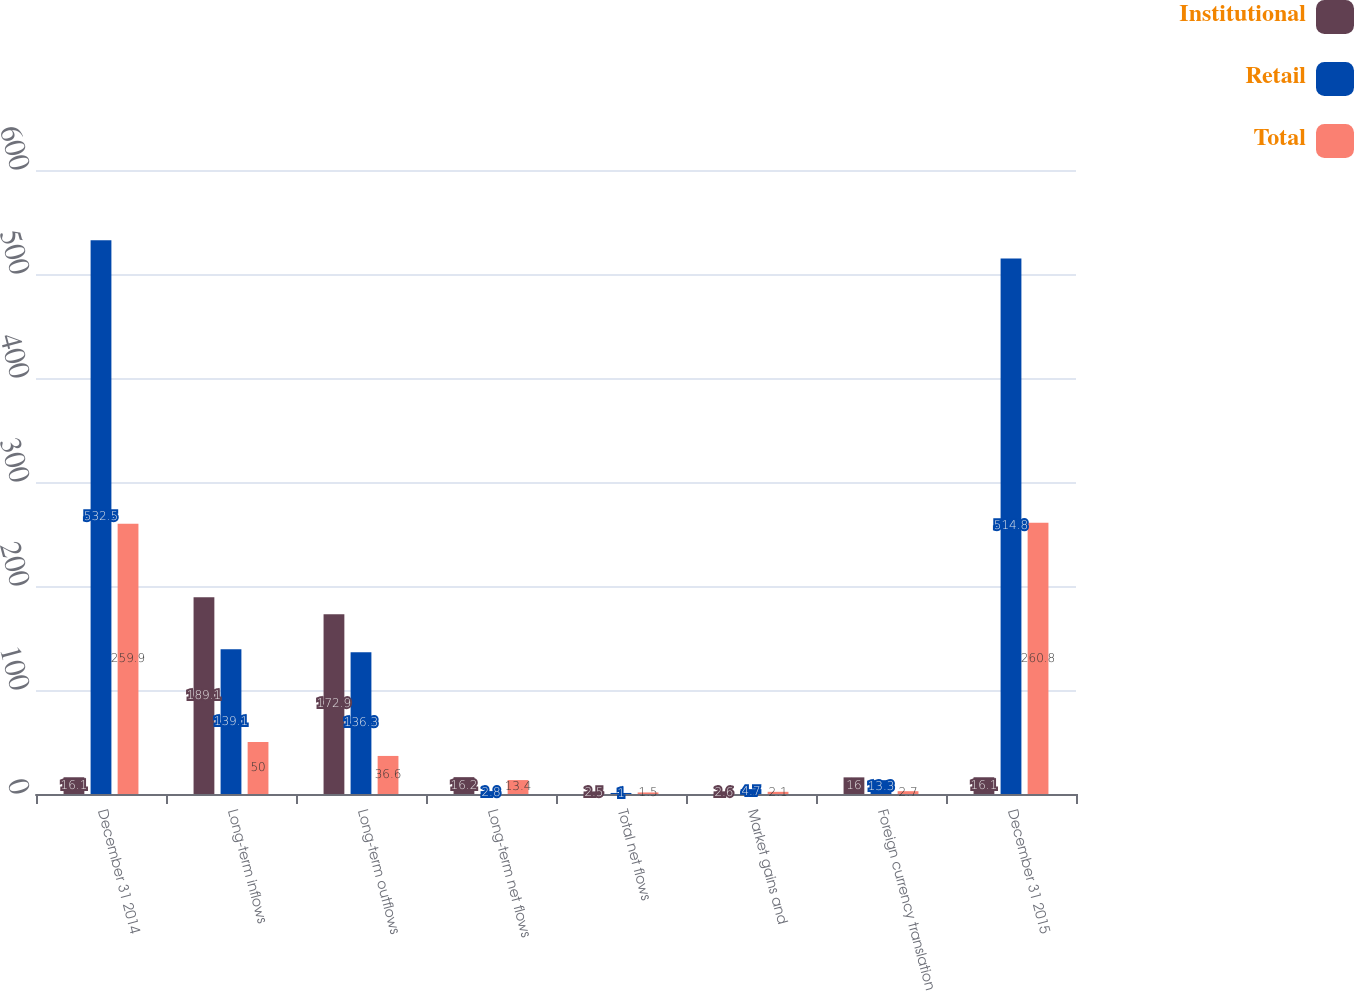Convert chart. <chart><loc_0><loc_0><loc_500><loc_500><stacked_bar_chart><ecel><fcel>December 31 2014<fcel>Long-term inflows<fcel>Long-term outflows<fcel>Long-term net flows<fcel>Total net flows<fcel>Market gains and<fcel>Foreign currency translation<fcel>December 31 2015<nl><fcel>Institutional<fcel>16.1<fcel>189.1<fcel>172.9<fcel>16.2<fcel>2.5<fcel>2.6<fcel>16<fcel>16.1<nl><fcel>Retail<fcel>532.5<fcel>139.1<fcel>136.3<fcel>2.8<fcel>1<fcel>4.7<fcel>13.3<fcel>514.8<nl><fcel>Total<fcel>259.9<fcel>50<fcel>36.6<fcel>13.4<fcel>1.5<fcel>2.1<fcel>2.7<fcel>260.8<nl></chart> 